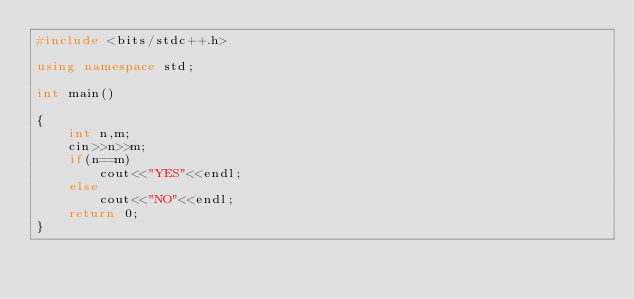<code> <loc_0><loc_0><loc_500><loc_500><_C++_>#include <bits/stdc++.h>

using namespace std;

int main()

{
    int n,m;
    cin>>n>>m;
    if(n==m)
        cout<<"YES"<<endl;
    else
        cout<<"NO"<<endl;
    return 0;
}
</code> 